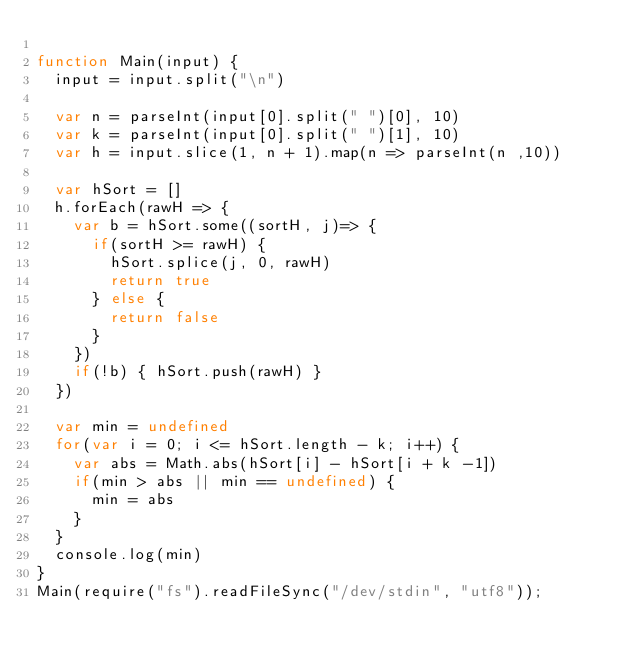Convert code to text. <code><loc_0><loc_0><loc_500><loc_500><_JavaScript_>
function Main(input) {
  input = input.split("\n")
 
  var n = parseInt(input[0].split(" ")[0], 10)
  var k = parseInt(input[0].split(" ")[1], 10)
  var h = input.slice(1, n + 1).map(n => parseInt(n ,10))
 
  var hSort = []
  h.forEach(rawH => {
    var b = hSort.some((sortH, j)=> {
      if(sortH >= rawH) {
        hSort.splice(j, 0, rawH)
        return true
      } else {
        return false
      }
    })
    if(!b) { hSort.push(rawH) }
  })
  
  var min = undefined
  for(var i = 0; i <= hSort.length - k; i++) {
    var abs = Math.abs(hSort[i] - hSort[i + k -1])
    if(min > abs || min == undefined) {
      min = abs
    }
  }
  console.log(min)
}
Main(require("fs").readFileSync("/dev/stdin", "utf8"));
</code> 